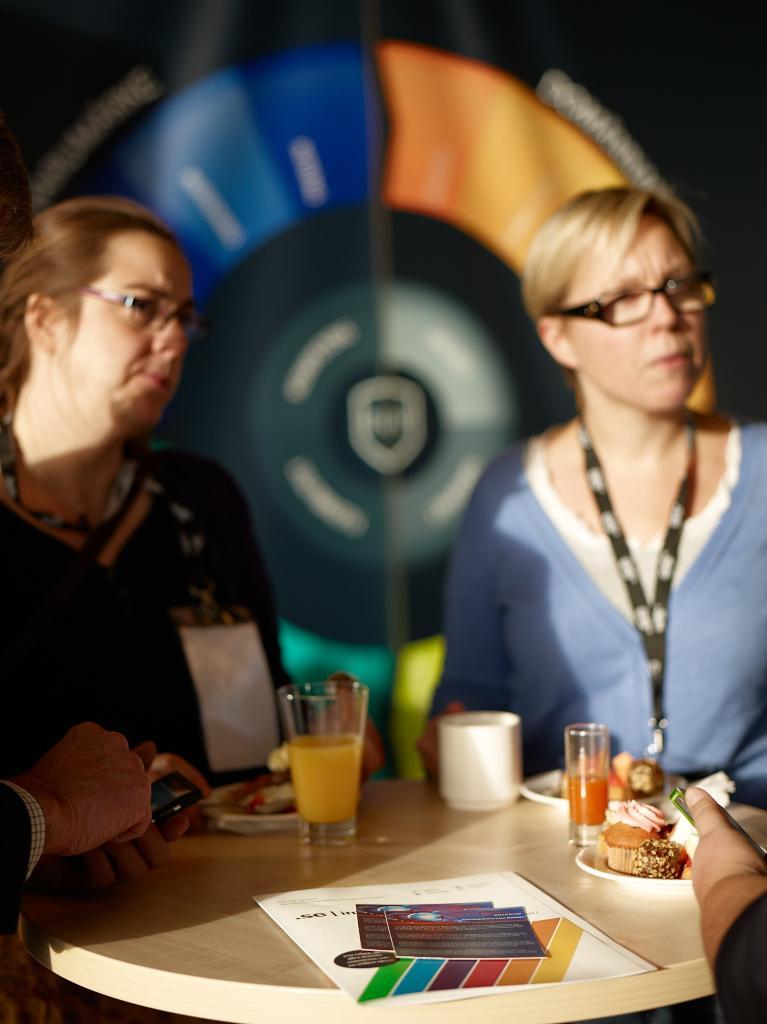Describe this image in one or two sentences. This picture shows two women seated on the chairs and we see a juice glass and a tea cup and a paper and some food in the plates on the table and we see a ID tag in one of the women's neck and we see a hand holding a mobile and we see a hoarding on the back 